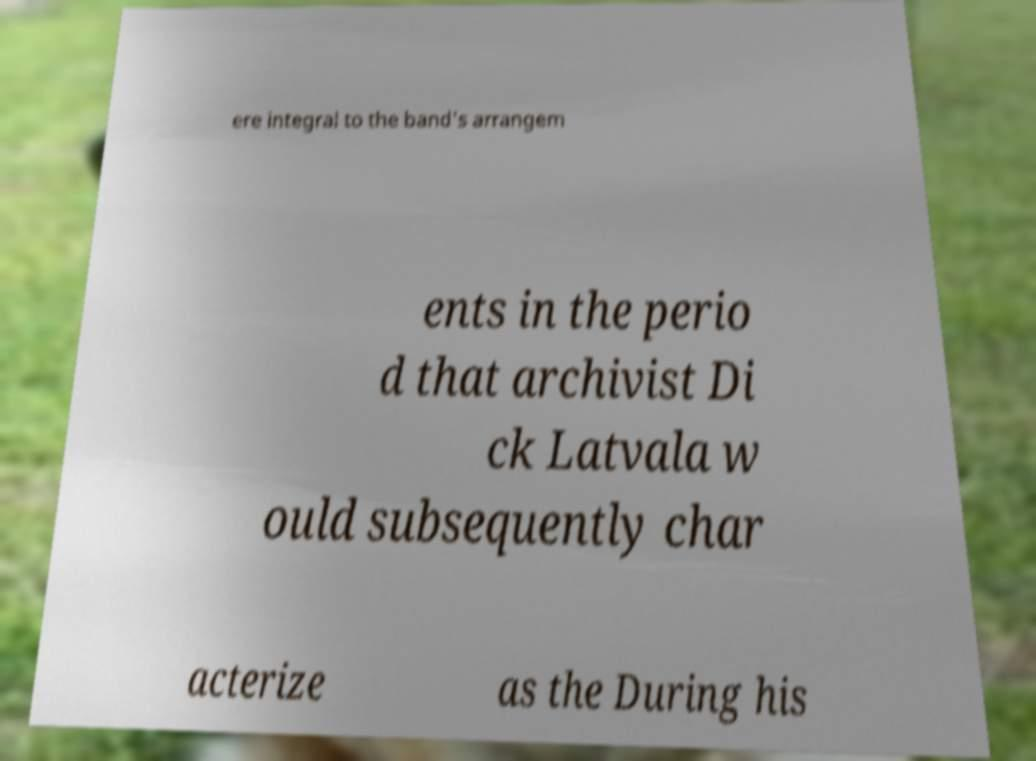There's text embedded in this image that I need extracted. Can you transcribe it verbatim? ere integral to the band's arrangem ents in the perio d that archivist Di ck Latvala w ould subsequently char acterize as the During his 